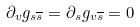Convert formula to latex. <formula><loc_0><loc_0><loc_500><loc_500>\partial _ { v } g _ { s \overline { s } } = \partial _ { s } g _ { v \overline { s } } = 0</formula> 